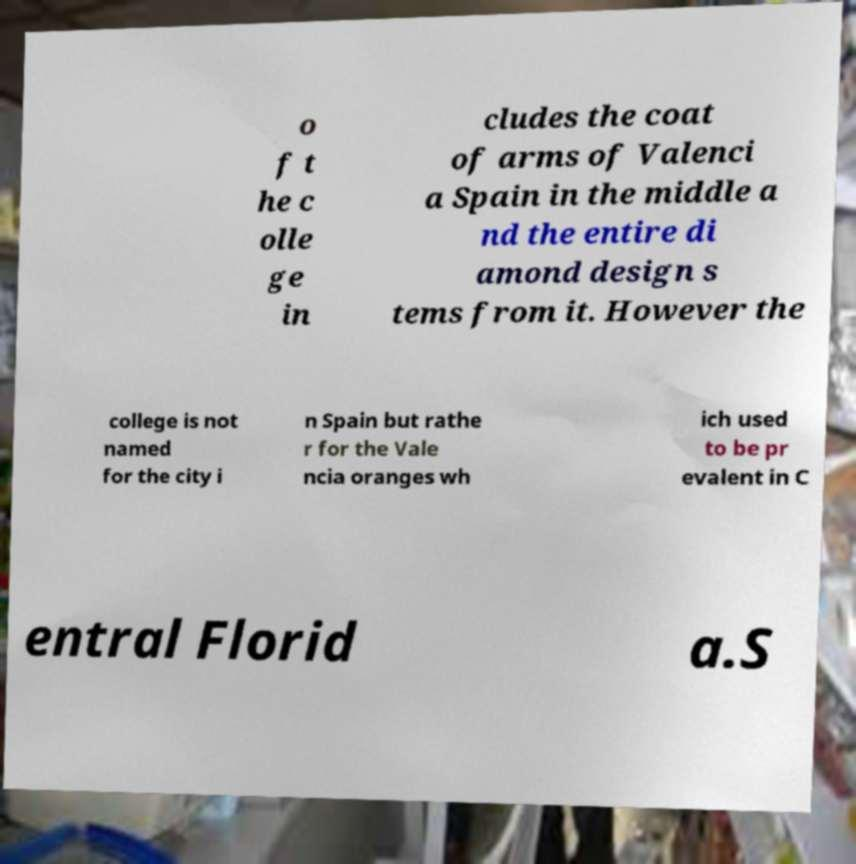What messages or text are displayed in this image? I need them in a readable, typed format. o f t he c olle ge in cludes the coat of arms of Valenci a Spain in the middle a nd the entire di amond design s tems from it. However the college is not named for the city i n Spain but rathe r for the Vale ncia oranges wh ich used to be pr evalent in C entral Florid a.S 